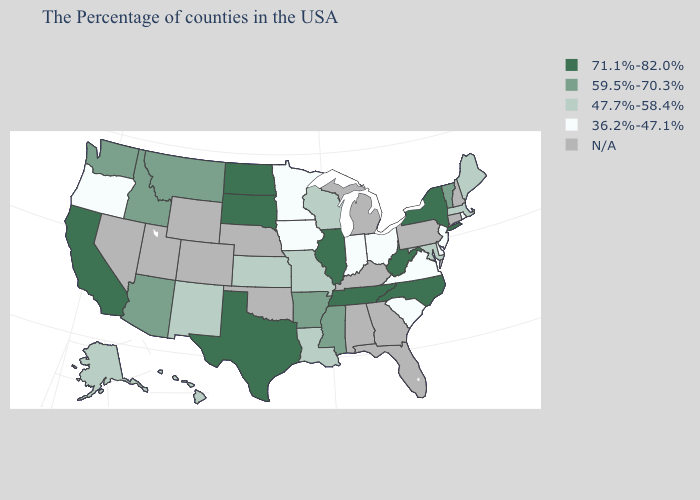What is the value of Washington?
Quick response, please. 59.5%-70.3%. What is the value of Arizona?
Short answer required. 59.5%-70.3%. Name the states that have a value in the range 71.1%-82.0%?
Keep it brief. New York, North Carolina, West Virginia, Tennessee, Illinois, Texas, South Dakota, North Dakota, California. Name the states that have a value in the range 47.7%-58.4%?
Concise answer only. Maine, Massachusetts, Maryland, Wisconsin, Louisiana, Missouri, Kansas, New Mexico, Alaska, Hawaii. Among the states that border New Hampshire , which have the lowest value?
Give a very brief answer. Maine, Massachusetts. How many symbols are there in the legend?
Give a very brief answer. 5. Name the states that have a value in the range 71.1%-82.0%?
Write a very short answer. New York, North Carolina, West Virginia, Tennessee, Illinois, Texas, South Dakota, North Dakota, California. Is the legend a continuous bar?
Give a very brief answer. No. Name the states that have a value in the range 36.2%-47.1%?
Quick response, please. Rhode Island, New Jersey, Delaware, Virginia, South Carolina, Ohio, Indiana, Minnesota, Iowa, Oregon. Does Ohio have the lowest value in the MidWest?
Write a very short answer. Yes. Which states have the lowest value in the South?
Quick response, please. Delaware, Virginia, South Carolina. What is the highest value in the MidWest ?
Write a very short answer. 71.1%-82.0%. Does Virginia have the lowest value in the USA?
Concise answer only. Yes. Name the states that have a value in the range N/A?
Short answer required. New Hampshire, Connecticut, Pennsylvania, Florida, Georgia, Michigan, Kentucky, Alabama, Nebraska, Oklahoma, Wyoming, Colorado, Utah, Nevada. What is the highest value in the West ?
Write a very short answer. 71.1%-82.0%. 